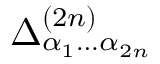<formula> <loc_0><loc_0><loc_500><loc_500>\Delta _ { \alpha _ { 1 } \dots \alpha _ { 2 n } } ^ { ( 2 n ) }</formula> 